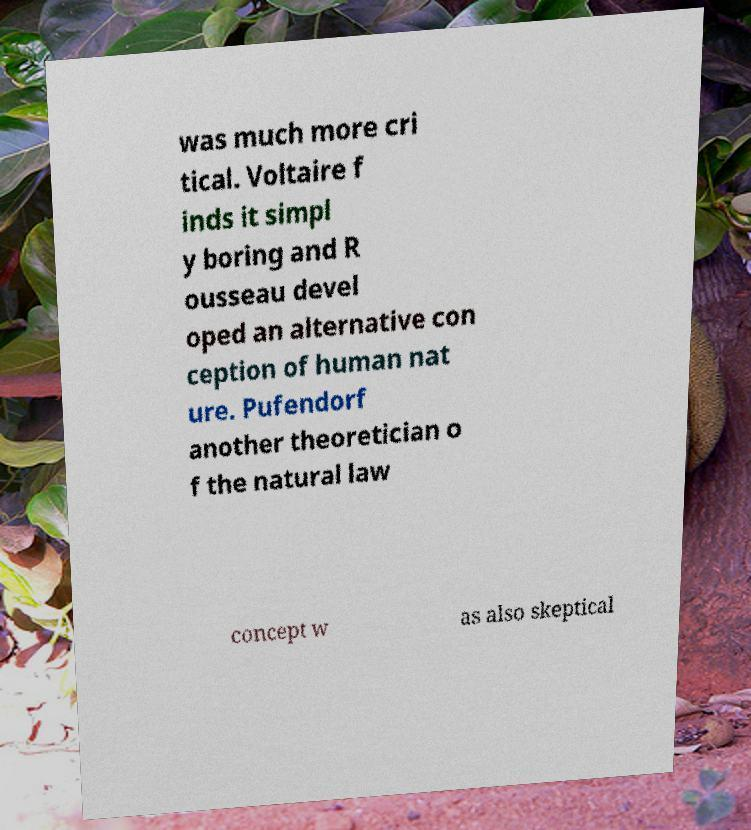Could you assist in decoding the text presented in this image and type it out clearly? was much more cri tical. Voltaire f inds it simpl y boring and R ousseau devel oped an alternative con ception of human nat ure. Pufendorf another theoretician o f the natural law concept w as also skeptical 